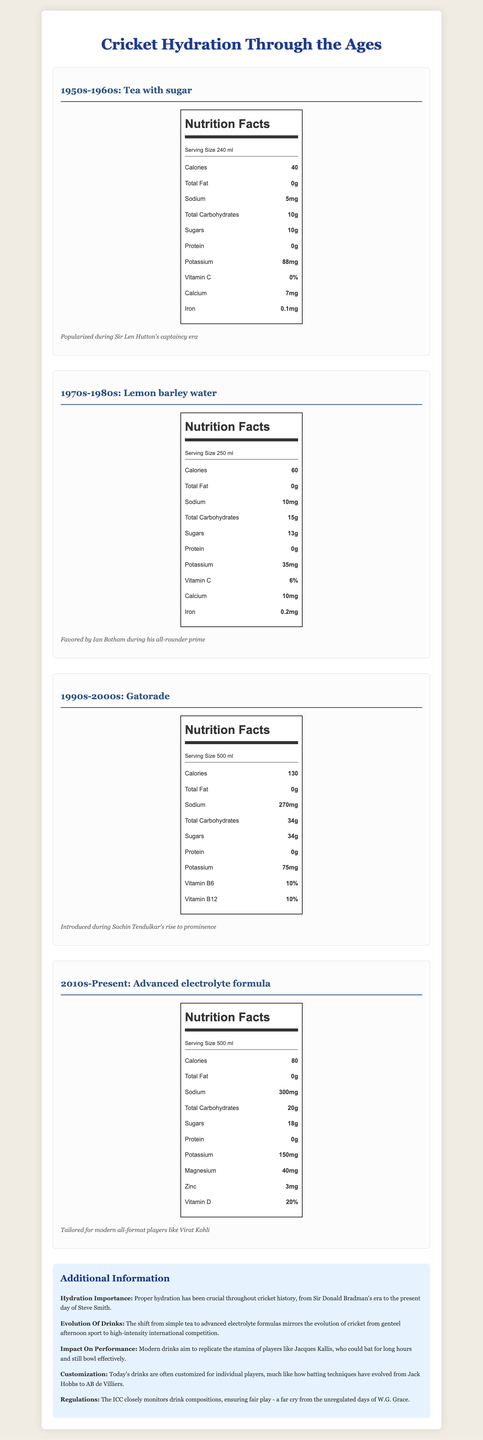what is the serving size of "Lemon barley water"? The serving size information is listed at the top of the nutrition facts for "Lemon barley water".
Answer: 250 ml which drink of the era has the highest sodium content? The "Advanced electrolyte formula" has 300mg of sodium, which is higher than the other drinks listed.
Answer: Advanced electrolyte formula what are the calories provided by "Gatorade"? "Gatorade" provides 130 calories according to the nutrition facts section of the document.
Answer: 130 calories who favored drinking "Tea with sugar" during their captaincy? The historical context mentions that "Tea with sugar" was popularized during Sir Len Hutton's captaincy era.
Answer: Sir Len Hutton what is the main source of carbohydrates in the "1950s-1960s" drink? The document specifies that "Tea with sugar" contains 10g of total carbohydrates, all of which are sugars.
Answer: Sugars which drink contains the highest amount of Vitamin D? "Advanced electrolyte formula" contains 20% of Vitamin D, the highest among the listed drinks.
Answer: Advanced electrolyte formula Which drink has the most potassium? A. Tea with sugar B. Lemon barley water C. Gatorade D. Advanced electrolyte formula "Advanced electrolyte formula" contains 150mg of potassium, which is higher than the potassium content in other drinks.
Answer: D. Advanced electrolyte formula Which drink was introduced during Sachin Tendulkar's rise to prominence? A. Tea with sugar B. Lemon barley water C. Gatorade D. Advanced electrolyte formula The historical context mentions that "Gatorade" was introduced during Sachin Tendulkar's rise to prominence.
Answer: C. Gatorade Does "Lemon barley water" contain protein? The nutrition facts for "Lemon barley water" show 0g of protein.
Answer: No Summarize the document The summary captures the essence of the document, emphasizing its focus on the changes in hydration drinks and their importance in cricket.
Answer: The document outlines the evolution of hydration drinks used in cricket across four different eras, from the 1950s to the present. It provides nutritional information for each drink and historical context, highlighting changes in hydration practices due to advancements in nutrition and the evolving demands of the sport. The document also provides additional insights on the importance of hydration, the impact on player performance, and modern customizations of hydration solutions. How has the customization of drinks evolved over time in Test matches? The document mentions that "Today's drinks are often customized for individual players," but it doesn't provide details on how customization has evolved over time.
Answer: Not enough information 